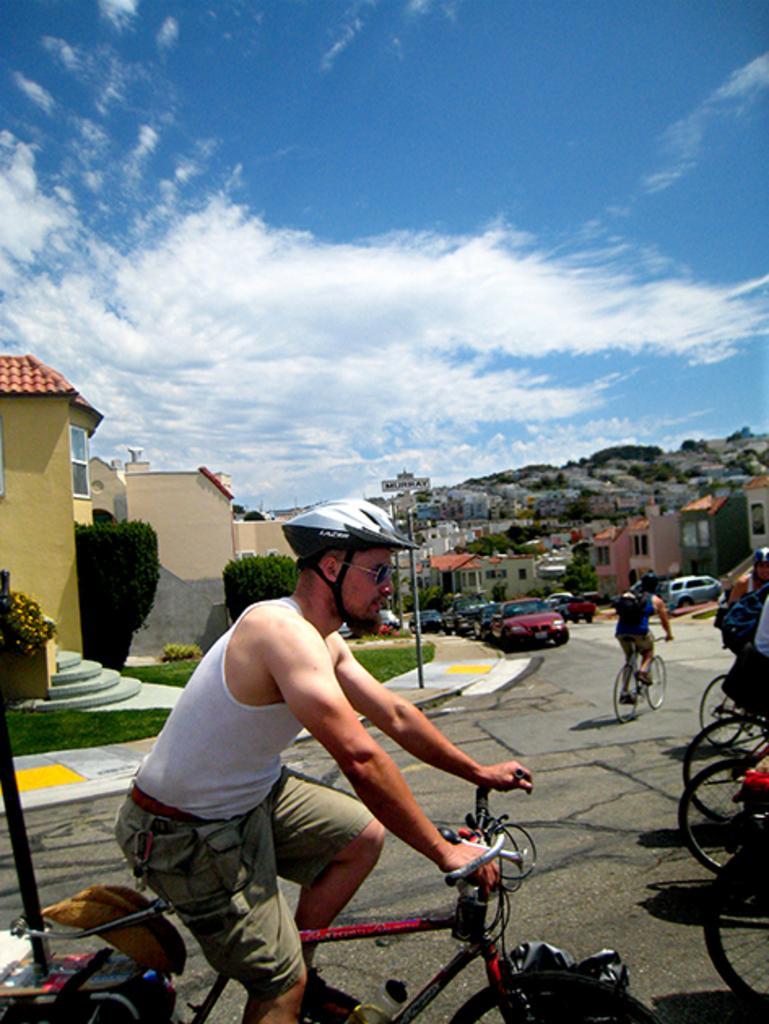Please provide a concise description of this image. In this picture we can see a man riding bicycle on road and in background we can see houses with steps and grass in front of that houses and some cars on the road and on far we can see hill and above the hill we can see sky with clouds and here it is a pole on foot path. This man wore helmet, goggles. 